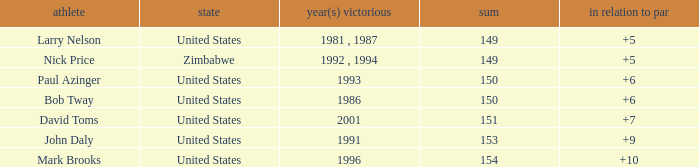Which player won in 1993? Paul Azinger. 